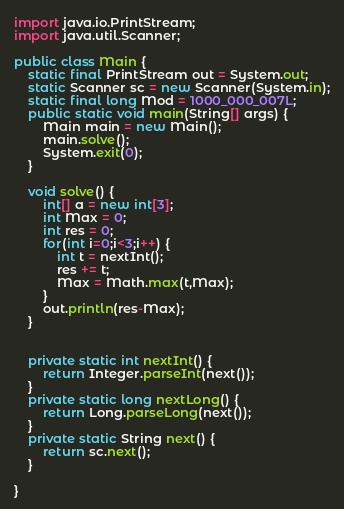Convert code to text. <code><loc_0><loc_0><loc_500><loc_500><_Java_>import java.io.PrintStream;
import java.util.Scanner;

public class Main {
	static final PrintStream out = System.out;
	static Scanner sc = new Scanner(System.in);
	static final long Mod = 1000_000_007L;
	public static void main(String[] args) {
		Main main = new Main();
		main.solve();
		System.exit(0);
	}

	void solve() {
		int[] a = new int[3];
		int Max = 0;
		int res = 0;
		for(int i=0;i<3;i++) {
			int t = nextInt();
			res += t;
			Max = Math.max(t,Max);
		}
		out.println(res-Max);
	}


	private static int nextInt() {
		return Integer.parseInt(next());
	}
	private static long nextLong() {
		return Long.parseLong(next());
	}
	private static String next() {
		return sc.next();
	}

}</code> 